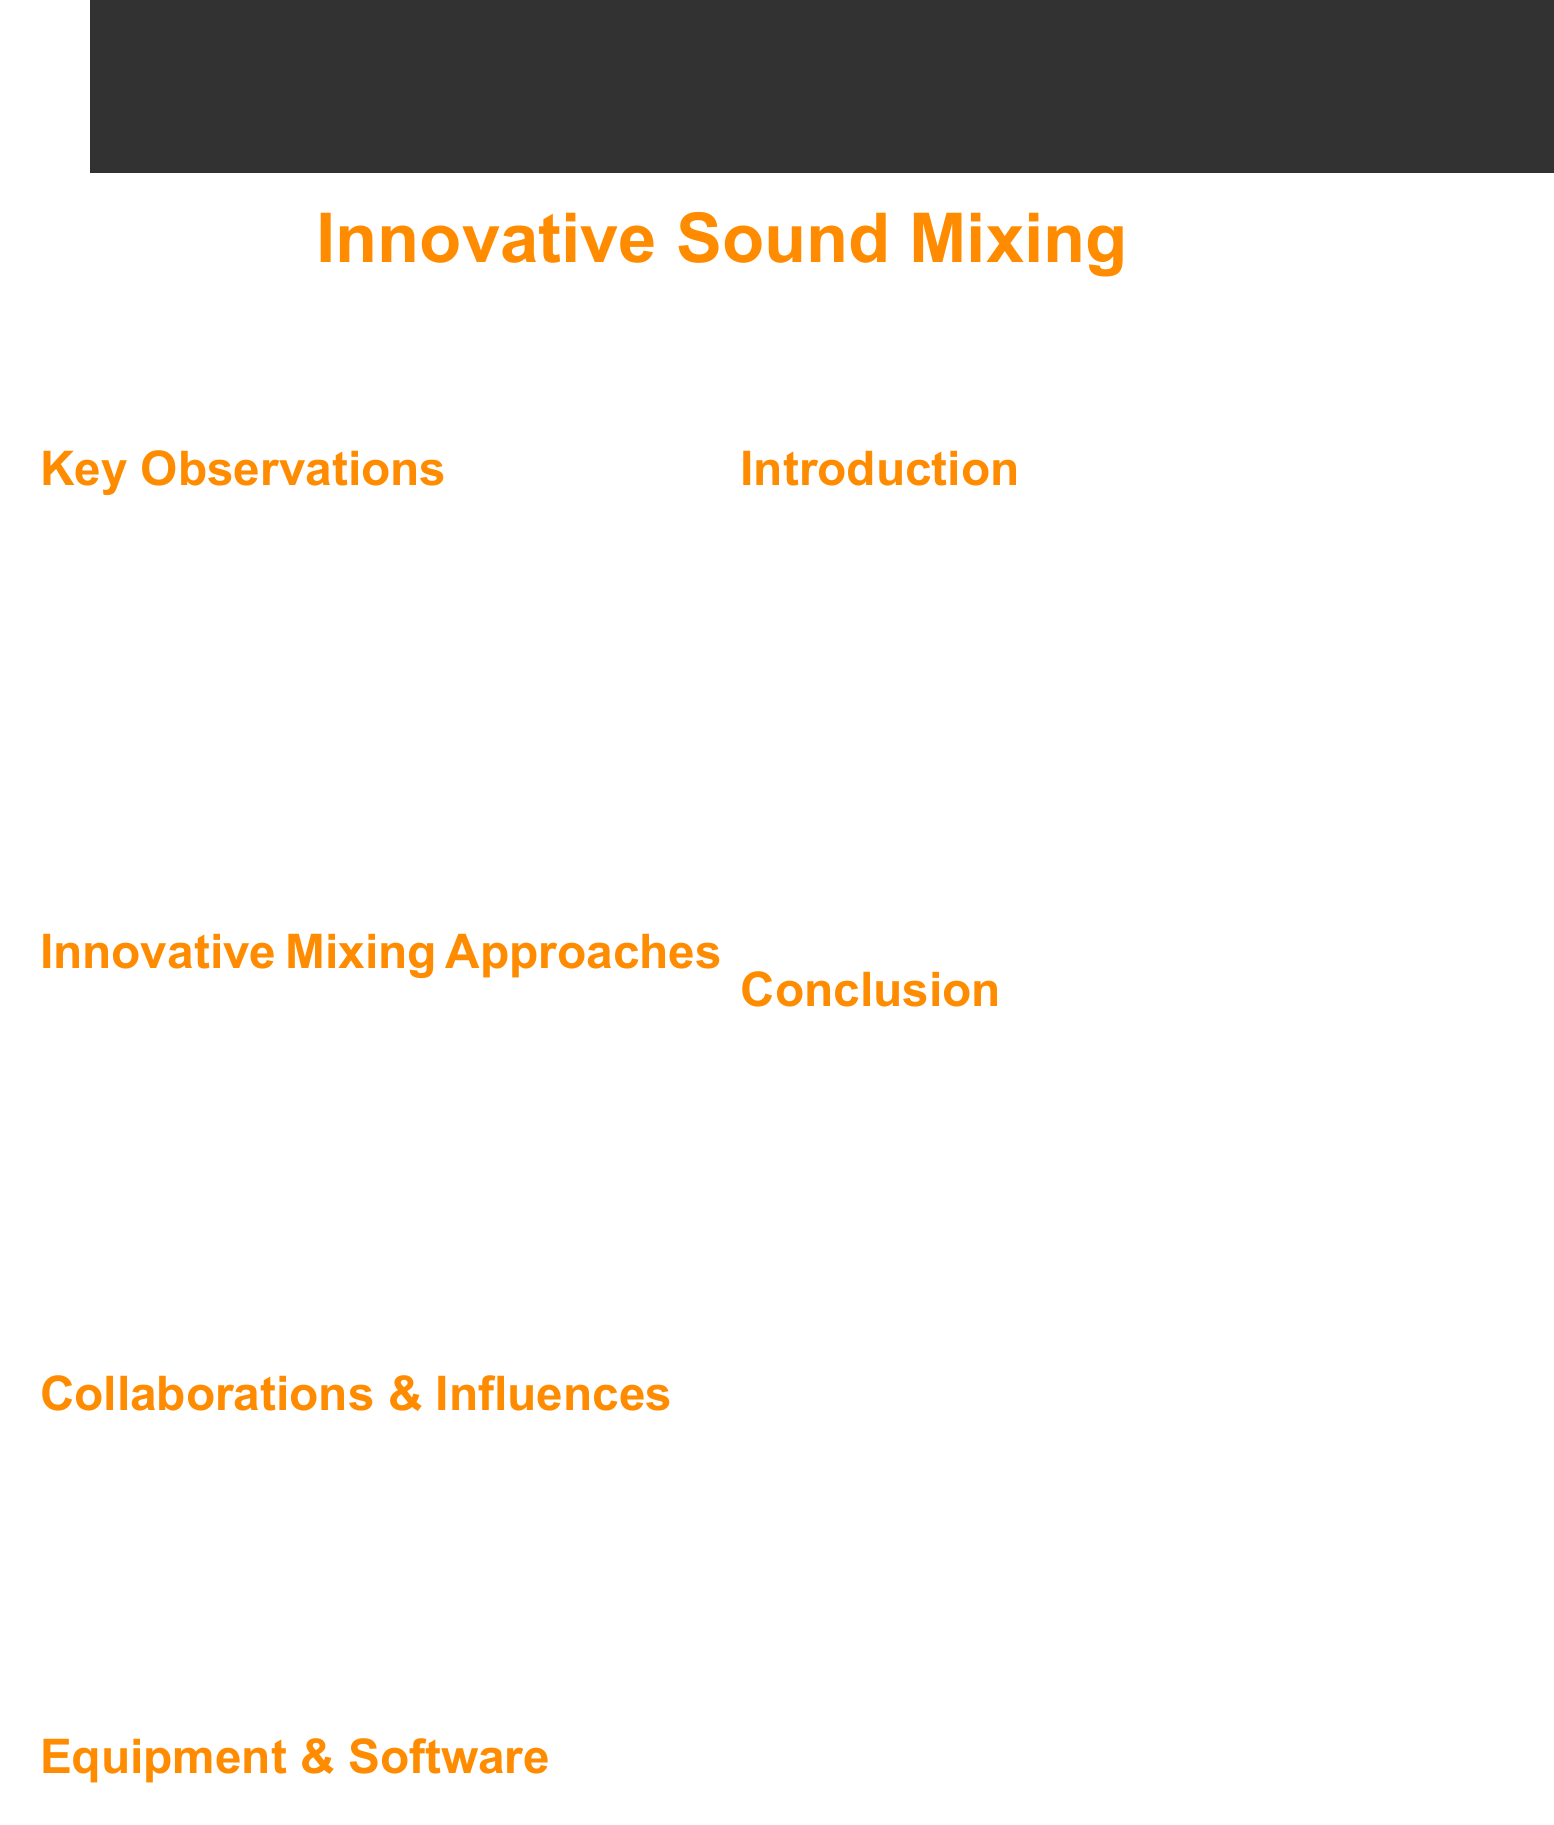What is the title of the document? The title appears prominently at the top, summarizing the main focus of the document.
Answer: Notes on Innovative Sound Mixing Techniques Inspired by Multi-Genre Dance Performances Who is one of the choreographers mentioned in the document? The document references influences and collaborations with specific choreographers, providing insight into sources of inspiration.
Answer: Wayne McGregor What technique is inspired by Flamenco? Each dance style has an associated innovative mixing technique, clearly outlined in the observations section.
Answer: Percussive Layering Which software is recommended as a DAW? The document specifies particular software and tools recommended for sound mixing, found in the equipment section.
Answer: Ableton Live 11 Suite What mixing approach uses 3D audio plugins? The innovative mixing approaches section discusses various techniques, including the one in question.
Answer: Spatial Audio Choreography What is a recommended plugin for rhythmic effects? The document provides a list of plugins in the equipment section for various sound design needs.
Answer: iZotope Stutter Edit 2 What dance styles are listed as key observations? The document outlines specific dance styles and their corresponding mixing techniques in a concise bullet format.
Answer: Contemporary Ballet, Breakdancing, Flamenco What inspired the technique of rhythmic stuttering? This technique is based on a specific dance style, as outlined in the key observations.
Answer: Breakdancing How does the document conclude? The conclusion summarizes the overarching theme and purpose of the notes, indicating the direction for future production work.
Answer: Expands creative palette and establishes unique sonic identity 